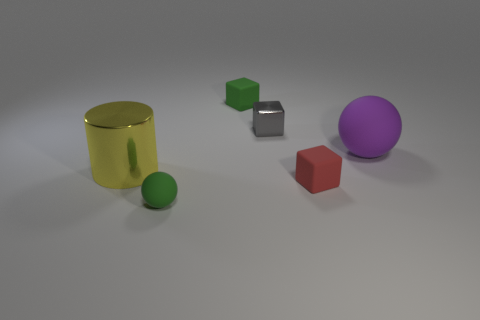There is a thing that is both behind the small red matte object and in front of the purple matte thing; what material is it?
Give a very brief answer. Metal. The sphere that is the same size as the metal block is what color?
Your answer should be very brief. Green. Is the material of the green sphere the same as the large thing that is on the left side of the red thing?
Keep it short and to the point. No. How many other things are there of the same size as the green rubber sphere?
Your answer should be compact. 3. Is there a shiny thing that is on the left side of the small rubber object that is to the right of the shiny thing to the right of the metal cylinder?
Make the answer very short. Yes. What is the size of the purple matte sphere?
Offer a terse response. Large. What size is the shiny object in front of the gray metal block?
Provide a succinct answer. Large. Does the rubber sphere on the left side of the gray block have the same size as the green matte block?
Give a very brief answer. Yes. Is there any other thing that is the same color as the tiny ball?
Ensure brevity in your answer.  Yes. What is the shape of the yellow shiny thing?
Provide a short and direct response. Cylinder. 